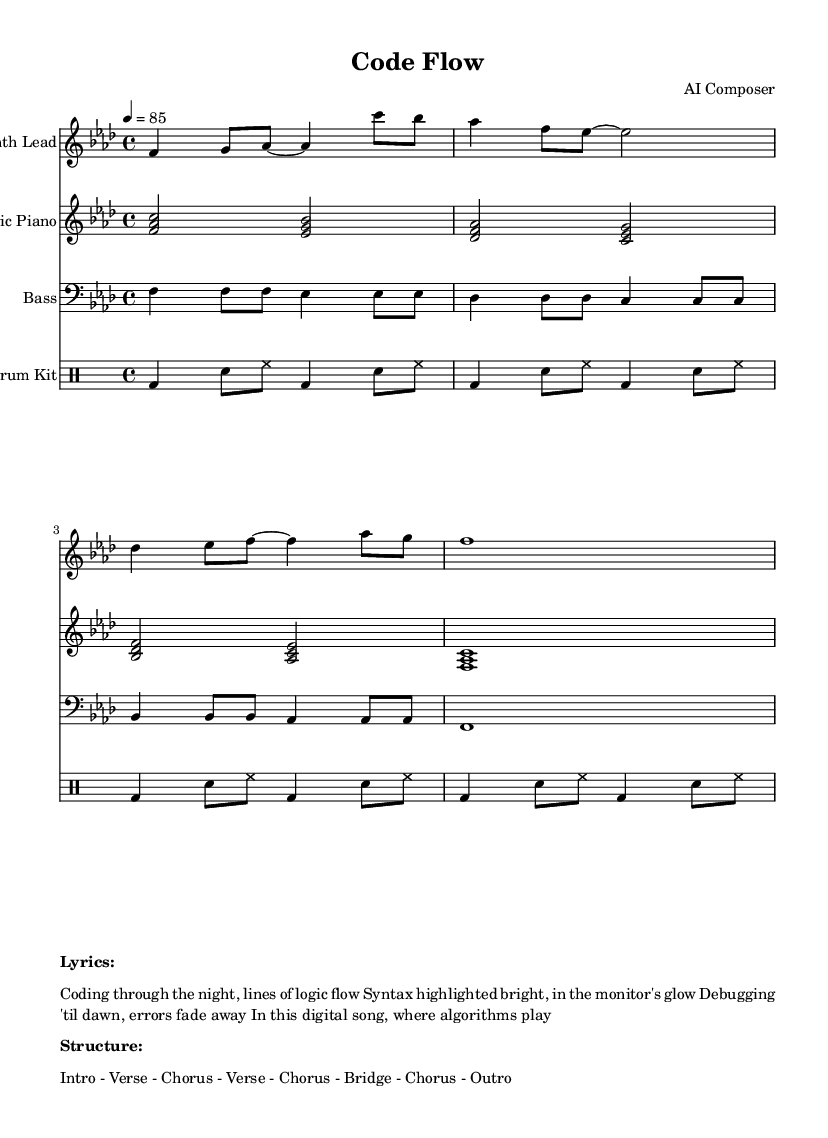What is the key signature of this music? The key signature indicated at the beginning of the score shows F minor, which has four flats (B♭, E♭, A♭, and D♭).
Answer: F minor What is the time signature of this music? The time signature shown at the beginning is four beats per measure, represented as 4/4, which means there are four quarter notes in each measure.
Answer: 4/4 What is the tempo of this piece? The tempo marking states that the quarter note is to be played at 85 beats per minute, providing a moderate pace for the music.
Answer: 85 How many instruments are in this score? The score contains four distinct staves, each representing a different instrument: Synth Lead, Electric Piano, Bass, and Drum Kit.
Answer: Four What is the structure of the song? The structure lists the order of sections in the piece. It includes an Intro, two Verses, two Choruses, a Bridge, and an Outro, totaling seven sections.
Answer: Intro - Verse - Chorus - Verse - Chorus - Bridge - Chorus - Outro What genre does this piece belong to? The piece is categorized under Rhythm and Blues, specifically noting its contemporary R&B style with electronic influences, suitable for late-night coding sessions.
Answer: Rhythm and Blues 